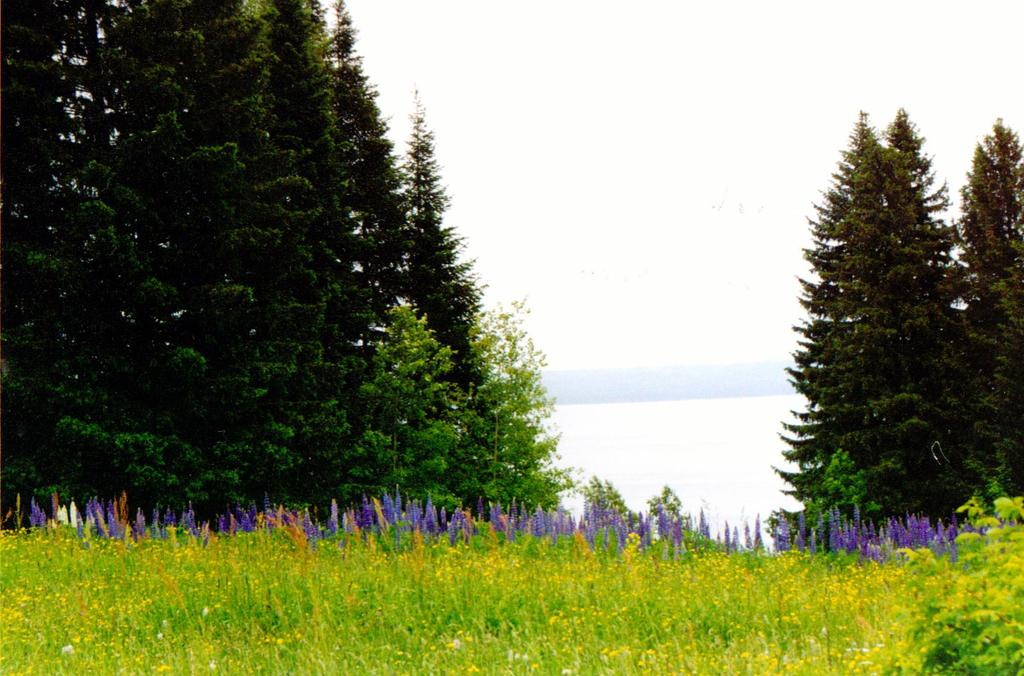What type of plants can be seen in the foreground of the image? There are flower plants in the foreground of the image. What is located on the left side of the image? There are trees on the left side of the image. What is located on the right side of the image? There are trees on the right side of the image. What can be seen in the sky in the image? Clouds are visible in the sky. How many pigs are visible in the image? There are no pigs present in the image. What type of hall can be seen in the background of the image? There is no hall present in the image. 